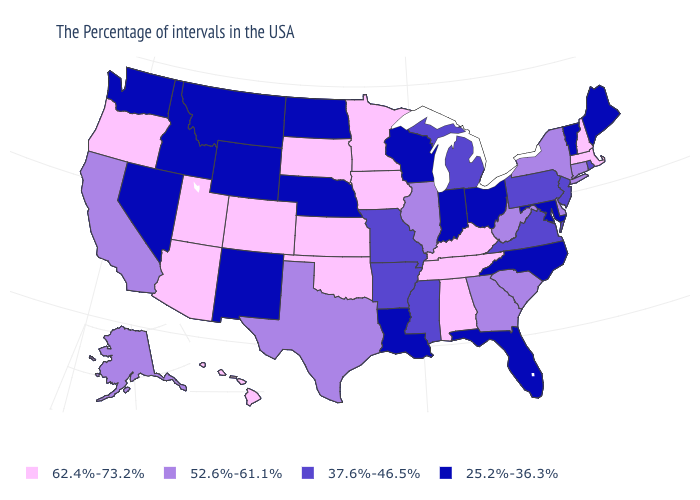Name the states that have a value in the range 37.6%-46.5%?
Short answer required. Rhode Island, New Jersey, Pennsylvania, Virginia, Michigan, Mississippi, Missouri, Arkansas. How many symbols are there in the legend?
Short answer required. 4. Does North Carolina have a lower value than Rhode Island?
Keep it brief. Yes. Which states have the lowest value in the South?
Keep it brief. Maryland, North Carolina, Florida, Louisiana. What is the value of Idaho?
Answer briefly. 25.2%-36.3%. Name the states that have a value in the range 52.6%-61.1%?
Give a very brief answer. Connecticut, New York, Delaware, South Carolina, West Virginia, Georgia, Illinois, Texas, California, Alaska. Does the first symbol in the legend represent the smallest category?
Quick response, please. No. Name the states that have a value in the range 37.6%-46.5%?
Keep it brief. Rhode Island, New Jersey, Pennsylvania, Virginia, Michigan, Mississippi, Missouri, Arkansas. What is the highest value in the USA?
Give a very brief answer. 62.4%-73.2%. Which states have the lowest value in the Northeast?
Write a very short answer. Maine, Vermont. Among the states that border Delaware , does Maryland have the highest value?
Be succinct. No. What is the value of Wyoming?
Answer briefly. 25.2%-36.3%. Name the states that have a value in the range 62.4%-73.2%?
Give a very brief answer. Massachusetts, New Hampshire, Kentucky, Alabama, Tennessee, Minnesota, Iowa, Kansas, Oklahoma, South Dakota, Colorado, Utah, Arizona, Oregon, Hawaii. Does Kentucky have the lowest value in the USA?
Write a very short answer. No. Which states have the highest value in the USA?
Give a very brief answer. Massachusetts, New Hampshire, Kentucky, Alabama, Tennessee, Minnesota, Iowa, Kansas, Oklahoma, South Dakota, Colorado, Utah, Arizona, Oregon, Hawaii. 